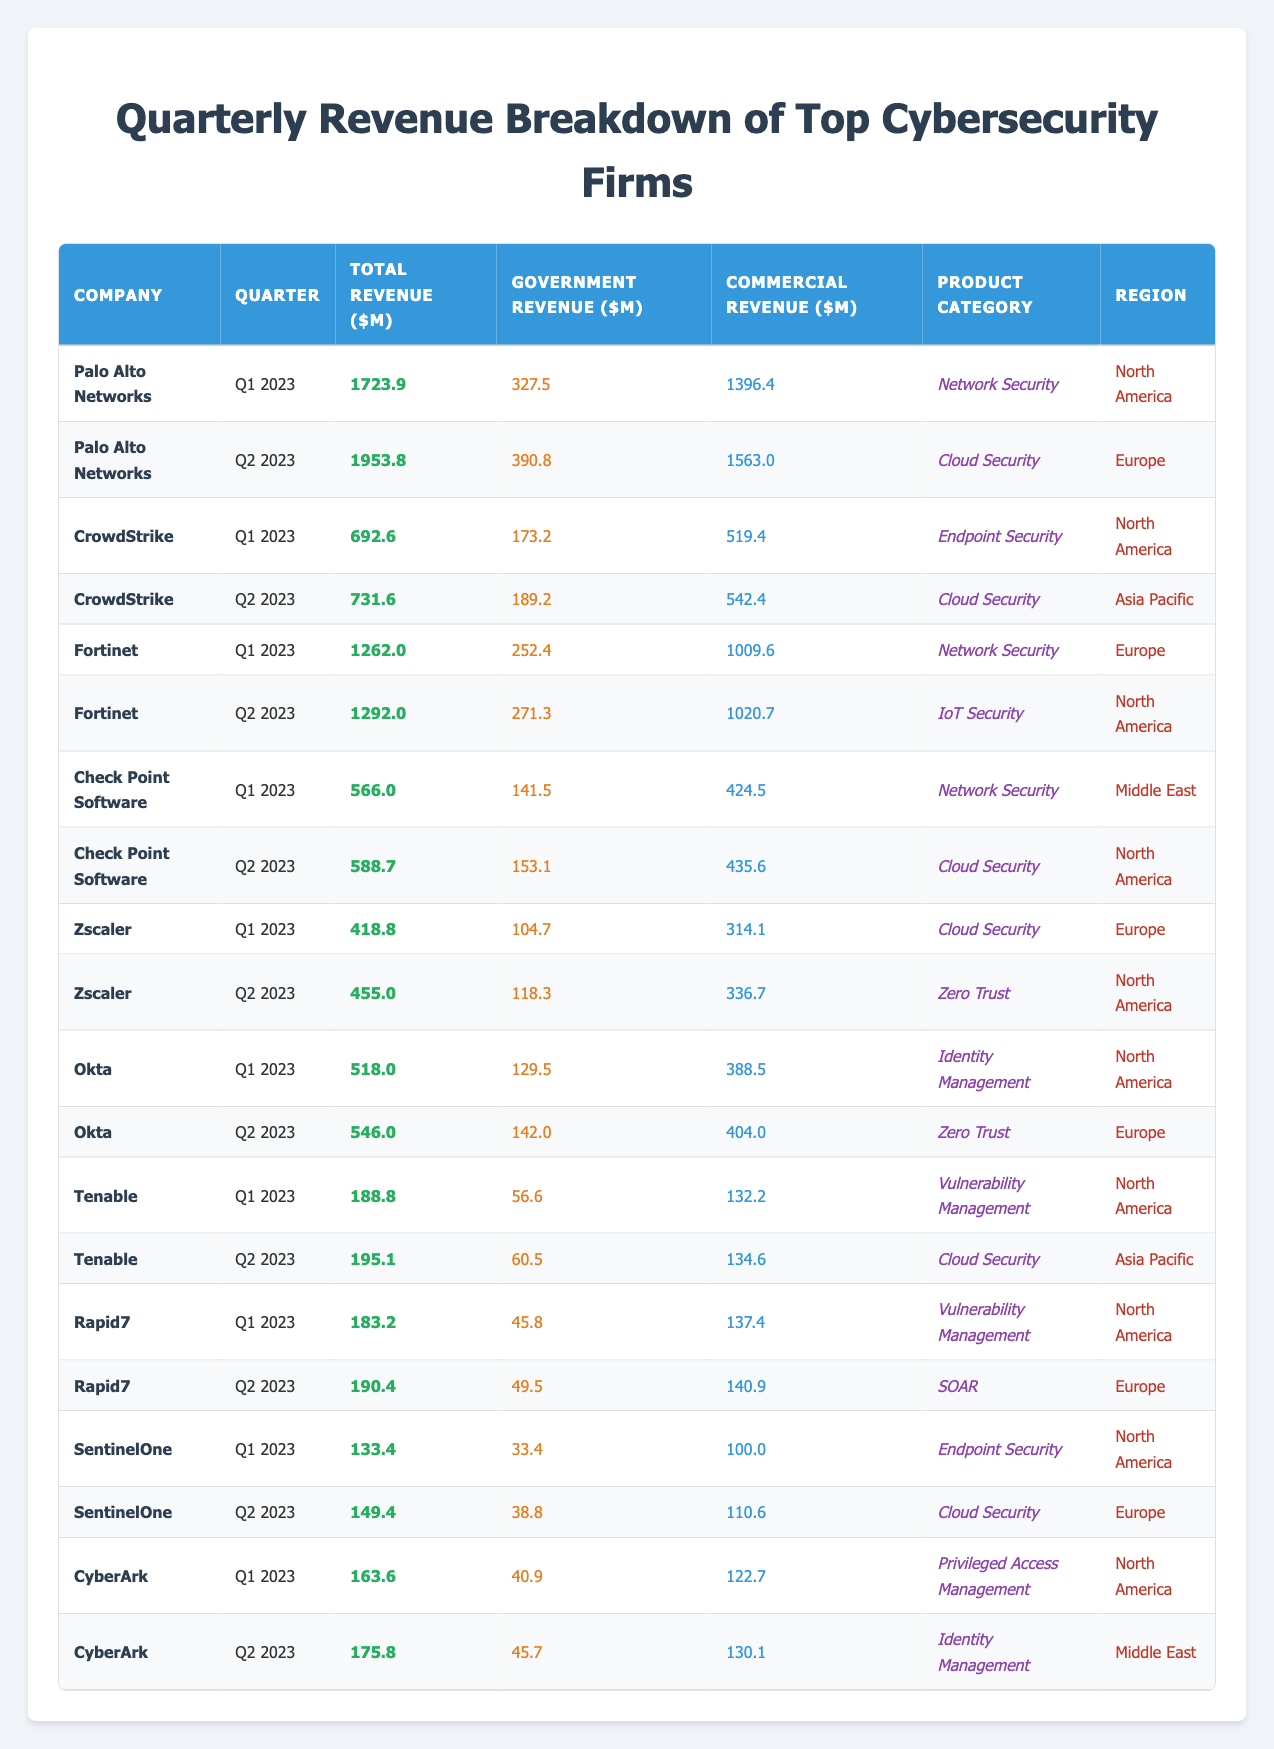What was the highest government revenue recorded by a single company in Q1 2023? The highest government revenue can be found by reviewing the Government Revenue column for Q1 2023. Palo Alto Networks has the highest government revenue of 327.5 million dollars.
Answer: 327.5 million dollars Which company had the least total revenue in Q2 2023? To find the least total revenue for Q2 2023, we look at the Total Revenue column specific to Q2 2023. Tenable had the least total revenue at 195.1 million dollars.
Answer: 195.1 million dollars What is the combined government revenue for CrowdStrike in both quarters of 2023? We find the government revenue for CrowdStrike in both Q1 and Q2 and then add them: Q1 is 173.2 million dollars and Q2 is 189.2 million dollars. So, the combined revenue is 173.2 + 189.2 = 362.4 million dollars.
Answer: 362.4 million dollars Did Check Point Software generate more government revenue than Fortinet in Q2 2023? We compare the government revenues: Check Point Software made 153.1 million dollars, while Fortinet made 271.3 million dollars in Q2 2023. Since 153.1 is less than 271.3, the answer is no.
Answer: No What is the average government revenue for Palo Alto Networks across the two quarters? We sum the government revenues for Palo Alto Networks in Q1 and Q2, which are 327.5 million and 390.8 million dollars. The average is (327.5 + 390.8) / 2 = 359.15 million dollars.
Answer: 359.15 million dollars 